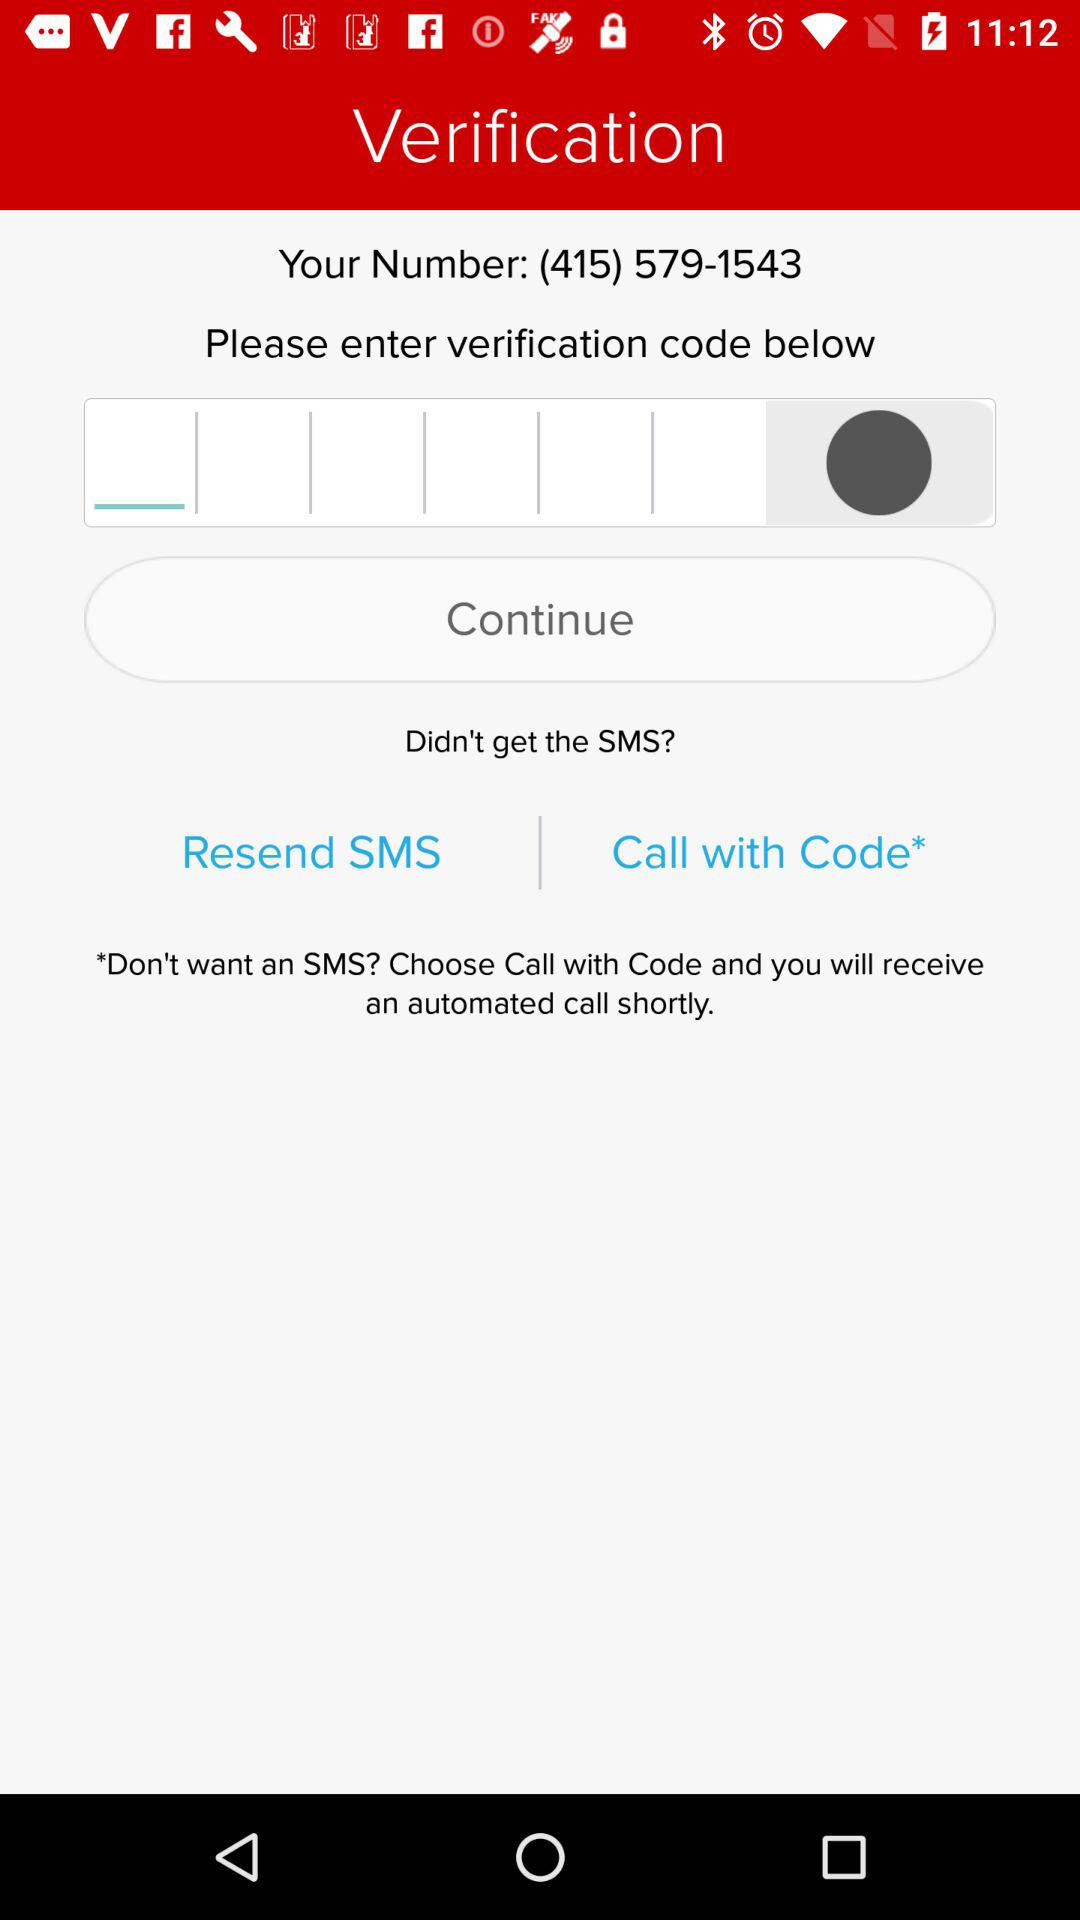What is the other option for verification, except "SMS"? The other option for verification is "Call with Code". 